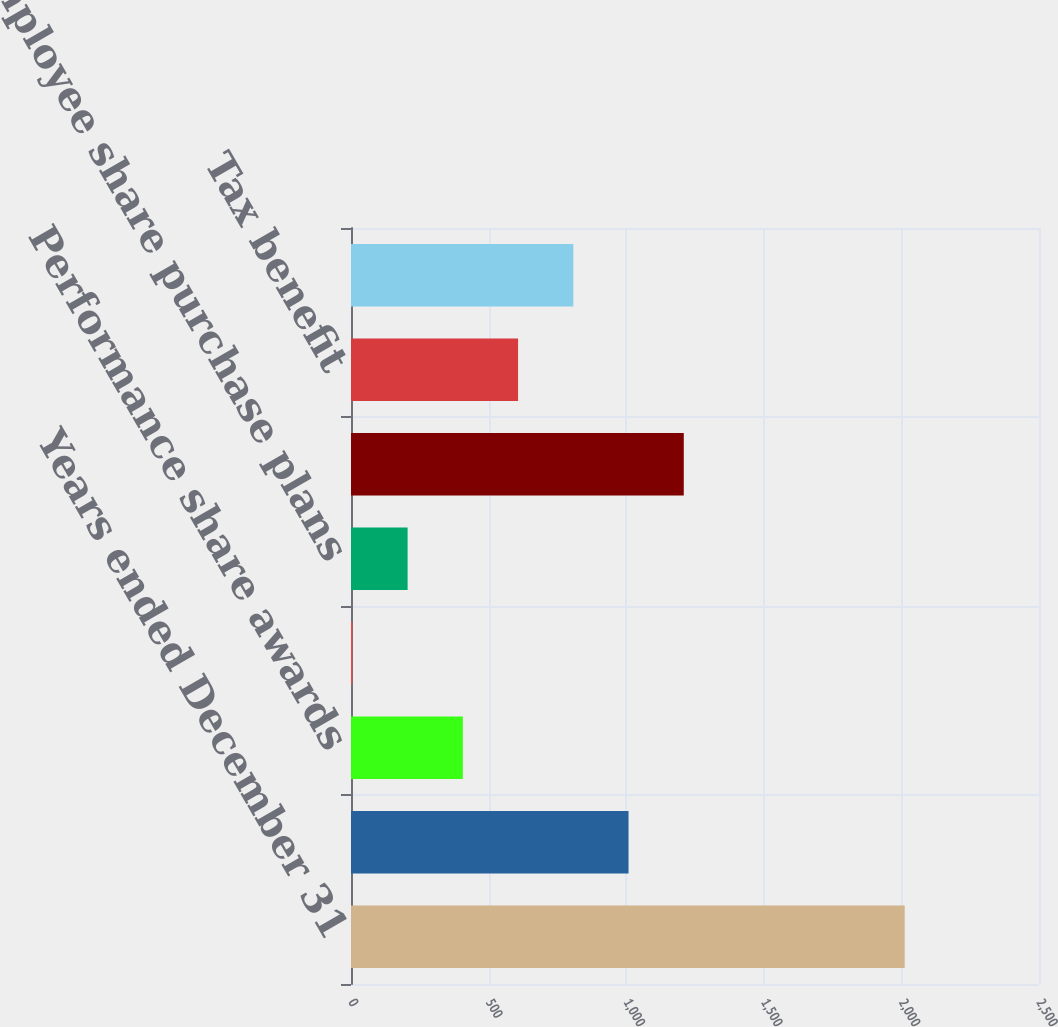<chart> <loc_0><loc_0><loc_500><loc_500><bar_chart><fcel>Years ended December 31<fcel>Restricted share units (RSUs)<fcel>Performance share awards<fcel>Share options<fcel>Employee share purchase plans<fcel>Total share-based compensation<fcel>Tax benefit<fcel>Share-based compensation<nl><fcel>2012<fcel>1008.5<fcel>406.4<fcel>5<fcel>205.7<fcel>1209.2<fcel>607.1<fcel>807.8<nl></chart> 